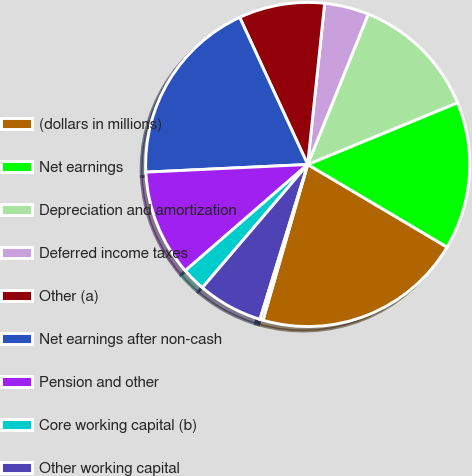Convert chart. <chart><loc_0><loc_0><loc_500><loc_500><pie_chart><fcel>(dollars in millions)<fcel>Net earnings<fcel>Depreciation and amortization<fcel>Deferred income taxes<fcel>Other (a)<fcel>Net earnings after non-cash<fcel>Pension and other<fcel>Core working capital (b)<fcel>Other working capital<fcel>Total<nl><fcel>20.93%<fcel>14.74%<fcel>12.68%<fcel>4.43%<fcel>8.56%<fcel>18.86%<fcel>10.62%<fcel>2.37%<fcel>6.5%<fcel>0.31%<nl></chart> 